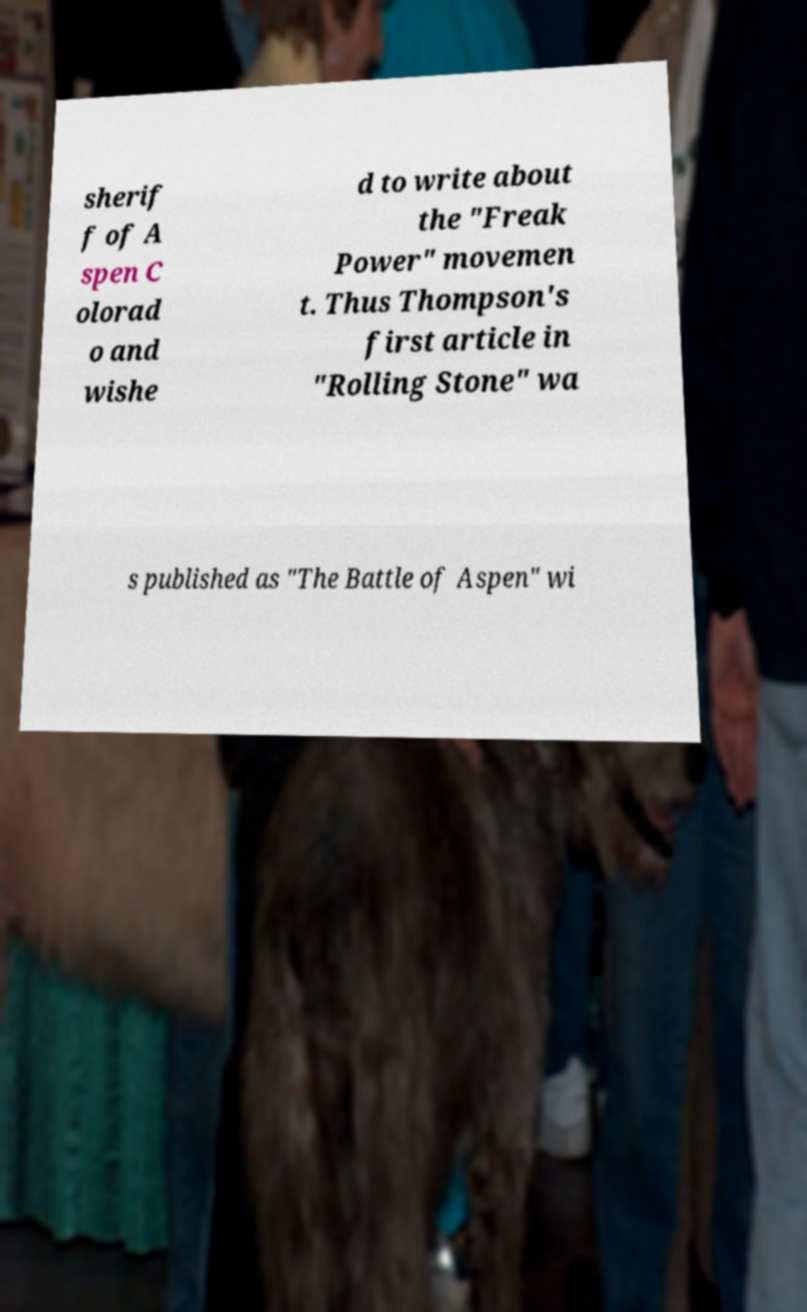I need the written content from this picture converted into text. Can you do that? sherif f of A spen C olorad o and wishe d to write about the "Freak Power" movemen t. Thus Thompson's first article in "Rolling Stone" wa s published as "The Battle of Aspen" wi 